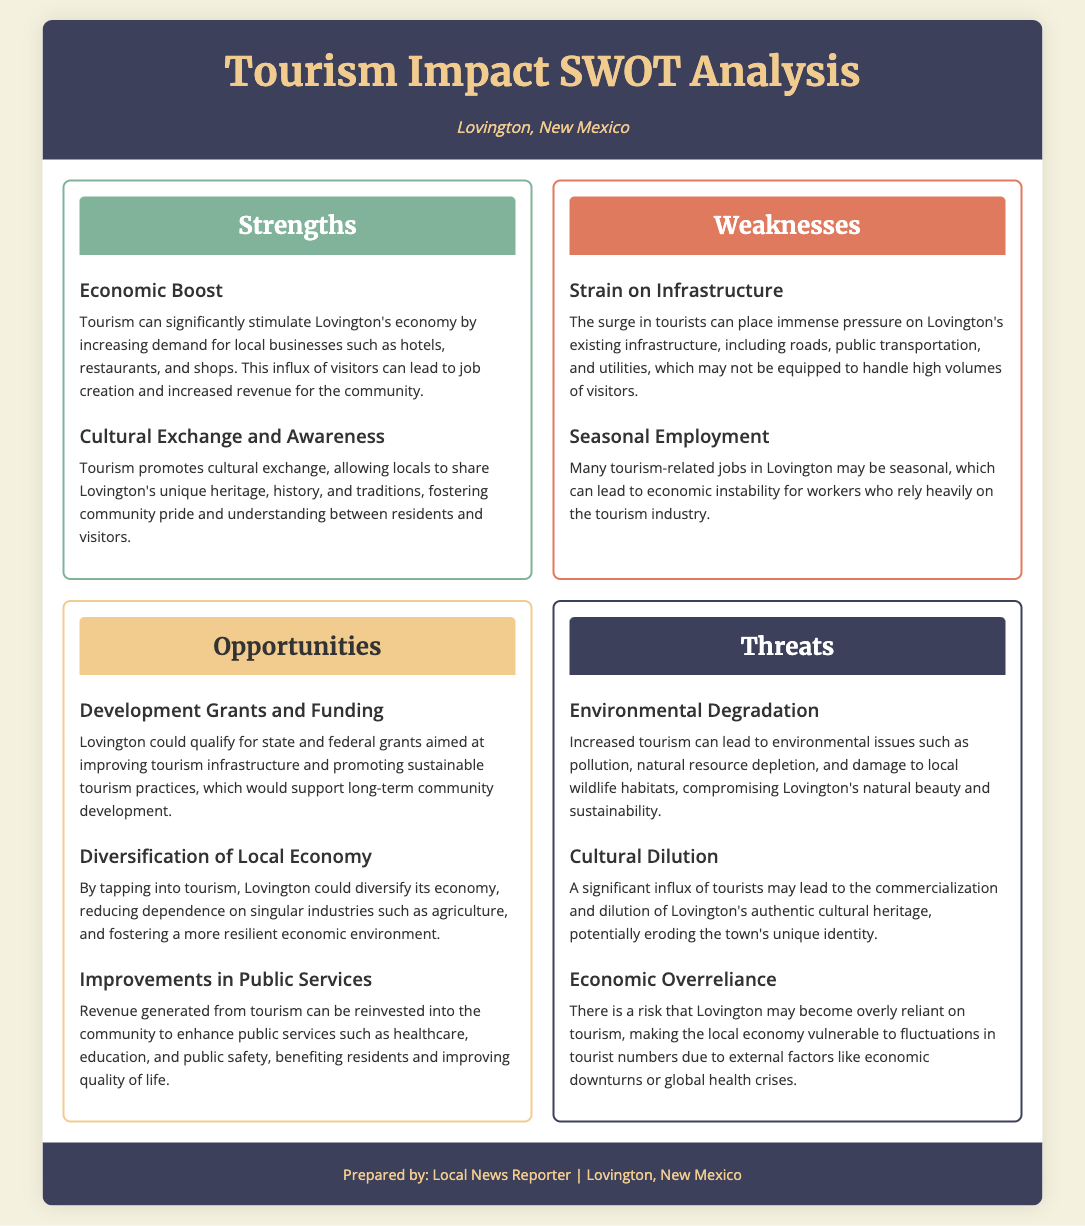What is one economic boost from tourism? The document states that tourism can significantly stimulate Lovington's economy by increasing demand for local businesses.
Answer: Increase demand for local businesses What are two weaknesses of tourism in Lovington? The document lists "Strain on Infrastructure" and "Seasonal Employment" as weaknesses of tourism.
Answer: Strain on Infrastructure, Seasonal Employment What opportunity involves funding? The document mentions "Development Grants and Funding" as an opportunity for Lovington.
Answer: Development Grants and Funding What is a potential environmental threat from increased tourism? The document cites "Environmental Degradation" as a threat related to tourism.
Answer: Environmental Degradation What does tourism promote in regards to local culture? The document indicates that tourism promotes "Cultural Exchange and Awareness."
Answer: Cultural Exchange and Awareness How can tourism improve public services in Lovington? The document explains that revenue generated from tourism can be reinvested into public services to enhance them.
Answer: Reinvested into public services What is one threat related to cultural identity? The document mentions "Cultural Dilution" as a threat to Lovington's cultural identity due to tourism.
Answer: Cultural Dilution What economic aspect could tourism help diversify? The document suggests that tourism could diversify Lovington's economy beyond singular industries like agriculture.
Answer: Local economy 